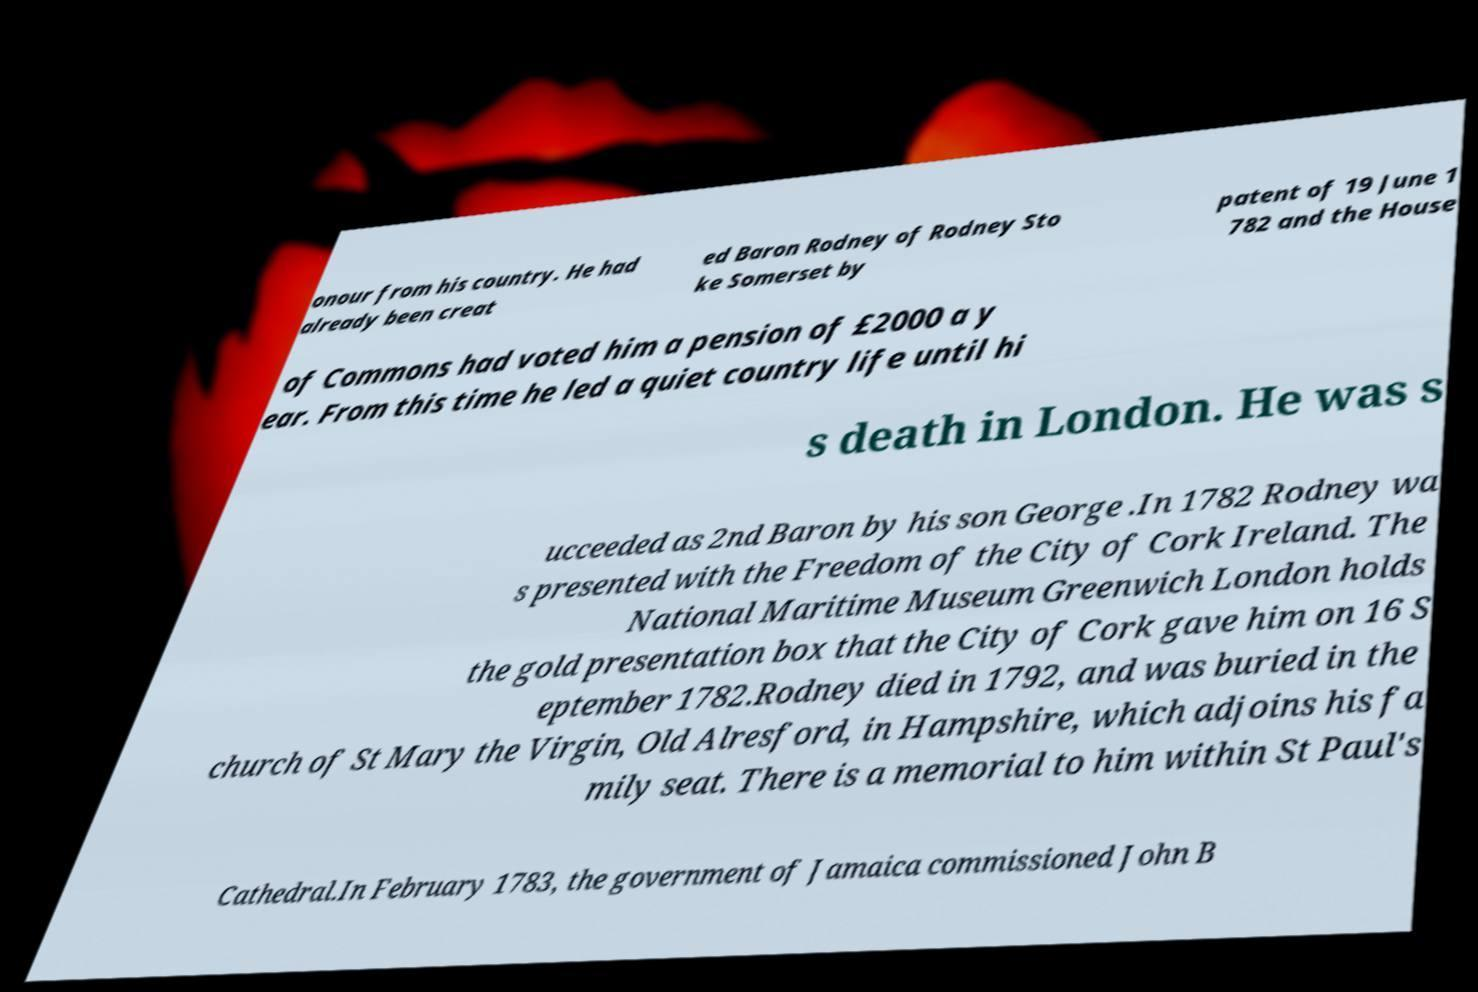There's text embedded in this image that I need extracted. Can you transcribe it verbatim? onour from his country. He had already been creat ed Baron Rodney of Rodney Sto ke Somerset by patent of 19 June 1 782 and the House of Commons had voted him a pension of £2000 a y ear. From this time he led a quiet country life until hi s death in London. He was s ucceeded as 2nd Baron by his son George .In 1782 Rodney wa s presented with the Freedom of the City of Cork Ireland. The National Maritime Museum Greenwich London holds the gold presentation box that the City of Cork gave him on 16 S eptember 1782.Rodney died in 1792, and was buried in the church of St Mary the Virgin, Old Alresford, in Hampshire, which adjoins his fa mily seat. There is a memorial to him within St Paul's Cathedral.In February 1783, the government of Jamaica commissioned John B 